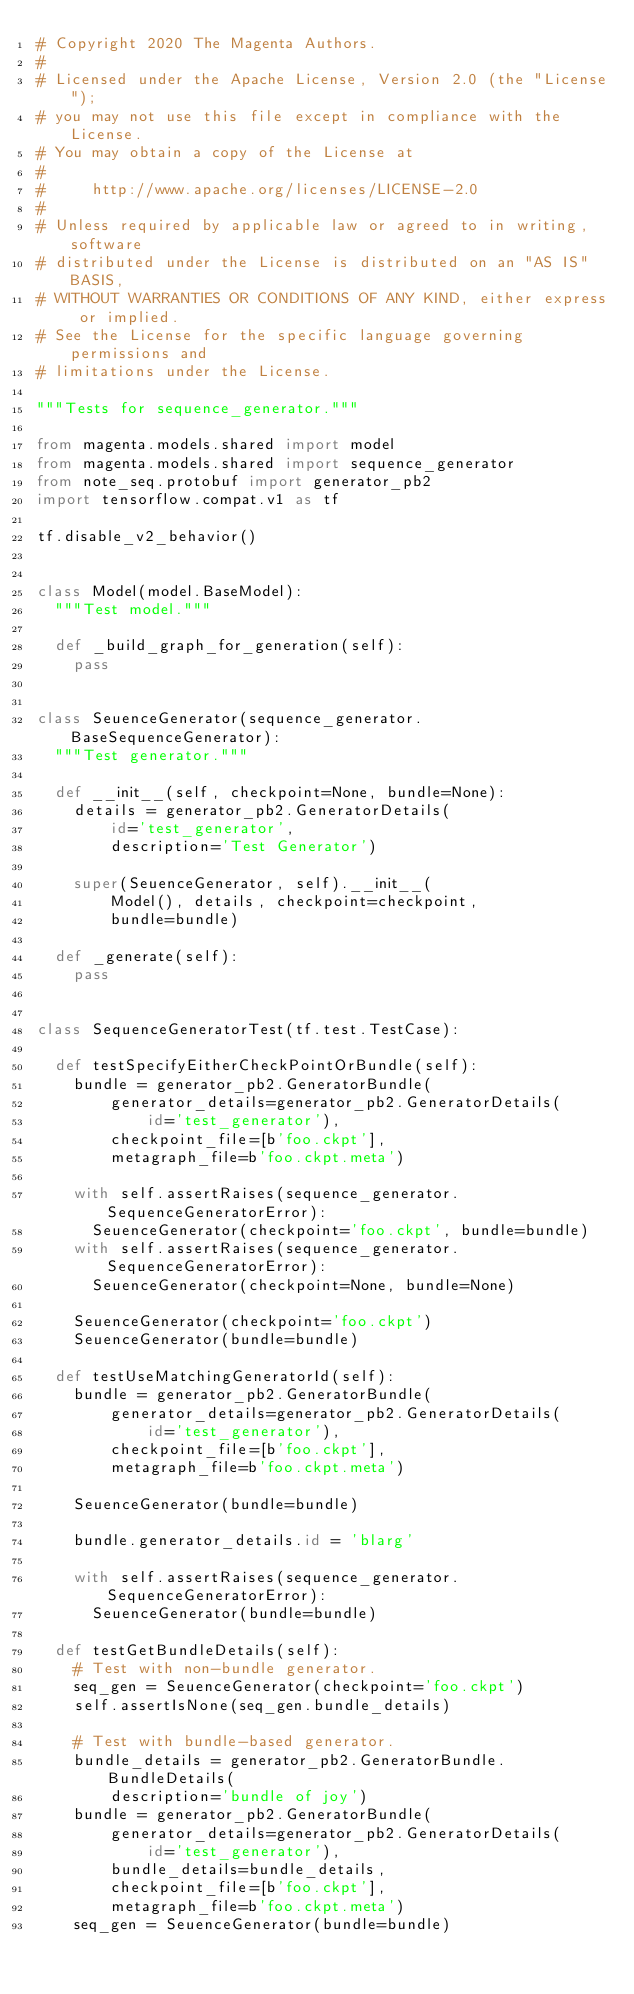<code> <loc_0><loc_0><loc_500><loc_500><_Python_># Copyright 2020 The Magenta Authors.
#
# Licensed under the Apache License, Version 2.0 (the "License");
# you may not use this file except in compliance with the License.
# You may obtain a copy of the License at
#
#     http://www.apache.org/licenses/LICENSE-2.0
#
# Unless required by applicable law or agreed to in writing, software
# distributed under the License is distributed on an "AS IS" BASIS,
# WITHOUT WARRANTIES OR CONDITIONS OF ANY KIND, either express or implied.
# See the License for the specific language governing permissions and
# limitations under the License.

"""Tests for sequence_generator."""

from magenta.models.shared import model
from magenta.models.shared import sequence_generator
from note_seq.protobuf import generator_pb2
import tensorflow.compat.v1 as tf

tf.disable_v2_behavior()


class Model(model.BaseModel):
  """Test model."""

  def _build_graph_for_generation(self):
    pass


class SeuenceGenerator(sequence_generator.BaseSequenceGenerator):
  """Test generator."""

  def __init__(self, checkpoint=None, bundle=None):
    details = generator_pb2.GeneratorDetails(
        id='test_generator',
        description='Test Generator')

    super(SeuenceGenerator, self).__init__(
        Model(), details, checkpoint=checkpoint,
        bundle=bundle)

  def _generate(self):
    pass


class SequenceGeneratorTest(tf.test.TestCase):

  def testSpecifyEitherCheckPointOrBundle(self):
    bundle = generator_pb2.GeneratorBundle(
        generator_details=generator_pb2.GeneratorDetails(
            id='test_generator'),
        checkpoint_file=[b'foo.ckpt'],
        metagraph_file=b'foo.ckpt.meta')

    with self.assertRaises(sequence_generator.SequenceGeneratorError):
      SeuenceGenerator(checkpoint='foo.ckpt', bundle=bundle)
    with self.assertRaises(sequence_generator.SequenceGeneratorError):
      SeuenceGenerator(checkpoint=None, bundle=None)

    SeuenceGenerator(checkpoint='foo.ckpt')
    SeuenceGenerator(bundle=bundle)

  def testUseMatchingGeneratorId(self):
    bundle = generator_pb2.GeneratorBundle(
        generator_details=generator_pb2.GeneratorDetails(
            id='test_generator'),
        checkpoint_file=[b'foo.ckpt'],
        metagraph_file=b'foo.ckpt.meta')

    SeuenceGenerator(bundle=bundle)

    bundle.generator_details.id = 'blarg'

    with self.assertRaises(sequence_generator.SequenceGeneratorError):
      SeuenceGenerator(bundle=bundle)

  def testGetBundleDetails(self):
    # Test with non-bundle generator.
    seq_gen = SeuenceGenerator(checkpoint='foo.ckpt')
    self.assertIsNone(seq_gen.bundle_details)

    # Test with bundle-based generator.
    bundle_details = generator_pb2.GeneratorBundle.BundleDetails(
        description='bundle of joy')
    bundle = generator_pb2.GeneratorBundle(
        generator_details=generator_pb2.GeneratorDetails(
            id='test_generator'),
        bundle_details=bundle_details,
        checkpoint_file=[b'foo.ckpt'],
        metagraph_file=b'foo.ckpt.meta')
    seq_gen = SeuenceGenerator(bundle=bundle)</code> 